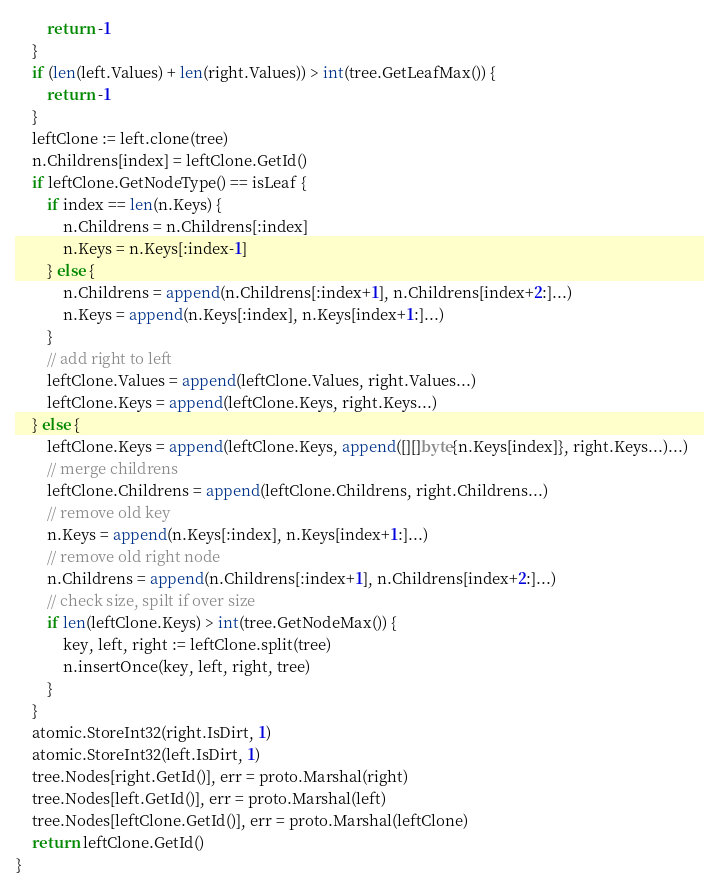Convert code to text. <code><loc_0><loc_0><loc_500><loc_500><_Go_>		return -1
	}
	if (len(left.Values) + len(right.Values)) > int(tree.GetLeafMax()) {
		return -1
	}
	leftClone := left.clone(tree)
	n.Childrens[index] = leftClone.GetId()
	if leftClone.GetNodeType() == isLeaf {
		if index == len(n.Keys) {
			n.Childrens = n.Childrens[:index]
			n.Keys = n.Keys[:index-1]
		} else {
			n.Childrens = append(n.Childrens[:index+1], n.Childrens[index+2:]...)
			n.Keys = append(n.Keys[:index], n.Keys[index+1:]...)
		}
		// add right to left
		leftClone.Values = append(leftClone.Values, right.Values...)
		leftClone.Keys = append(leftClone.Keys, right.Keys...)
	} else {
		leftClone.Keys = append(leftClone.Keys, append([][]byte{n.Keys[index]}, right.Keys...)...)
		// merge childrens
		leftClone.Childrens = append(leftClone.Childrens, right.Childrens...)
		// remove old key
		n.Keys = append(n.Keys[:index], n.Keys[index+1:]...)
		// remove old right node
		n.Childrens = append(n.Childrens[:index+1], n.Childrens[index+2:]...)
		// check size, spilt if over size
		if len(leftClone.Keys) > int(tree.GetNodeMax()) {
			key, left, right := leftClone.split(tree)
			n.insertOnce(key, left, right, tree)
		}
	}
	atomic.StoreInt32(right.IsDirt, 1)
	atomic.StoreInt32(left.IsDirt, 1)
	tree.Nodes[right.GetId()], err = proto.Marshal(right)
	tree.Nodes[left.GetId()], err = proto.Marshal(left)
	tree.Nodes[leftClone.GetId()], err = proto.Marshal(leftClone)
	return leftClone.GetId()
}
</code> 